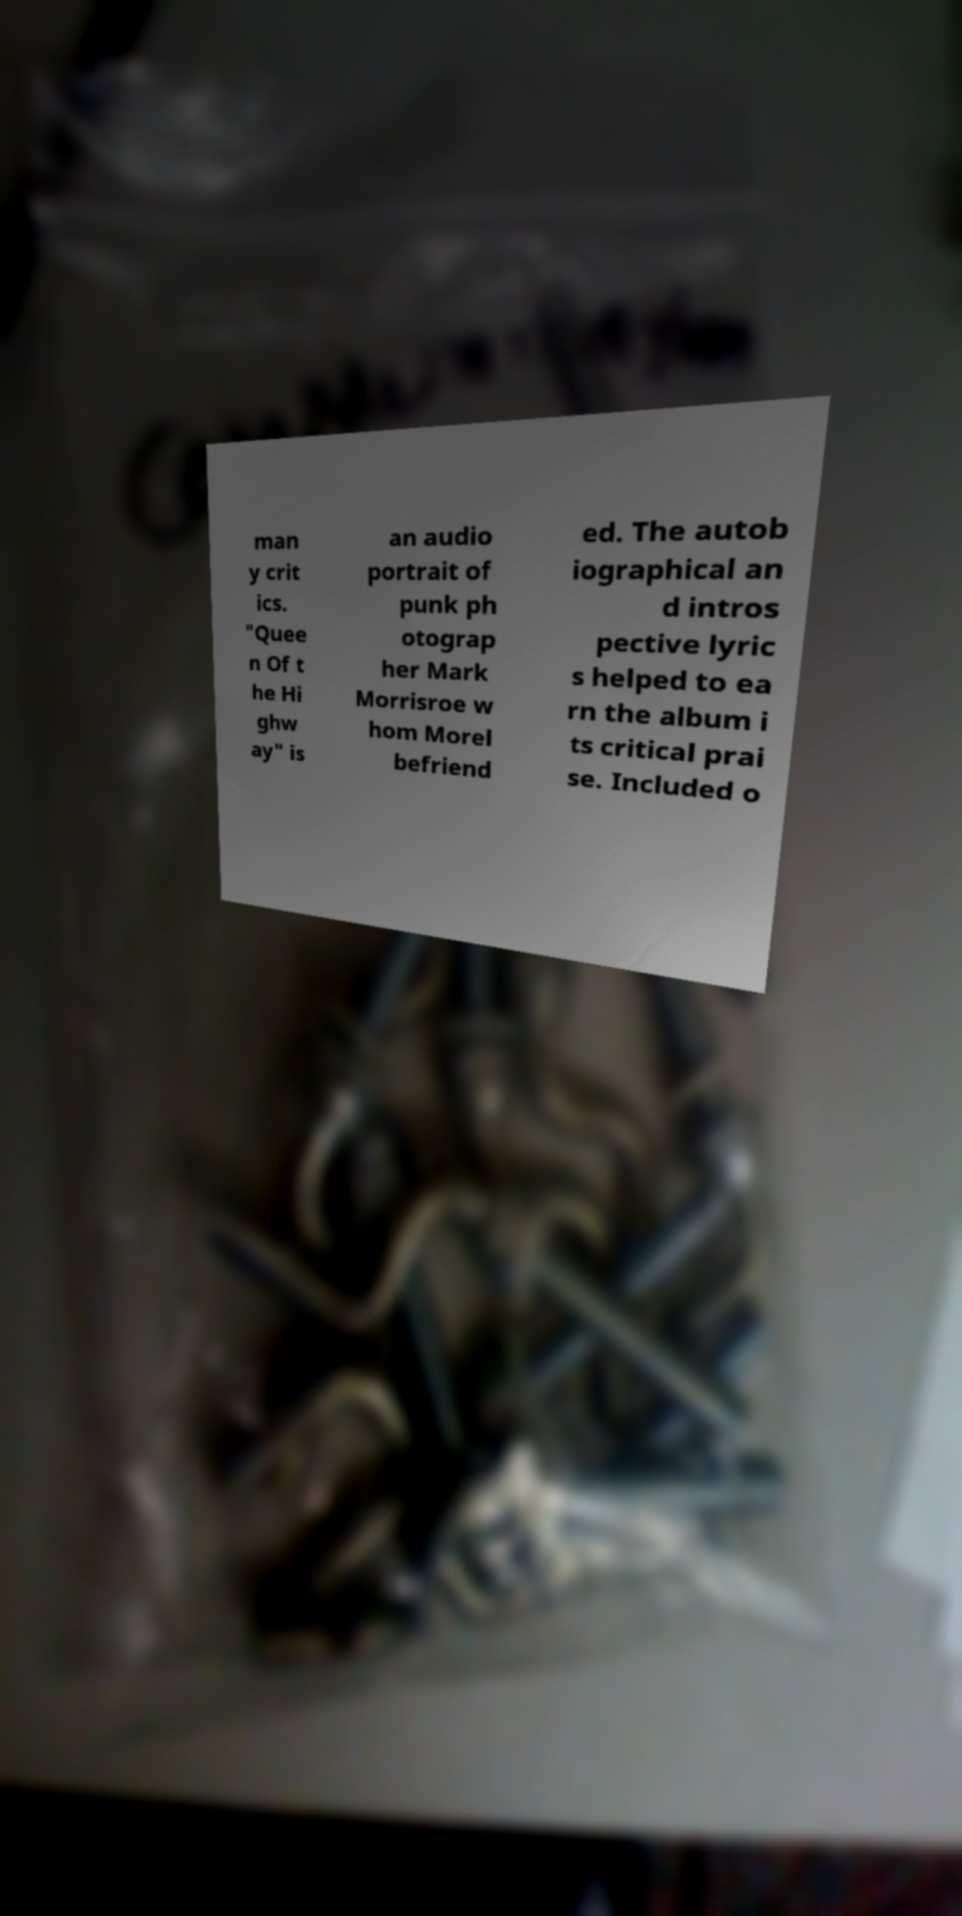Could you extract and type out the text from this image? man y crit ics. "Quee n Of t he Hi ghw ay" is an audio portrait of punk ph otograp her Mark Morrisroe w hom Morel befriend ed. The autob iographical an d intros pective lyric s helped to ea rn the album i ts critical prai se. Included o 